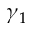Convert formula to latex. <formula><loc_0><loc_0><loc_500><loc_500>\gamma _ { 1 }</formula> 